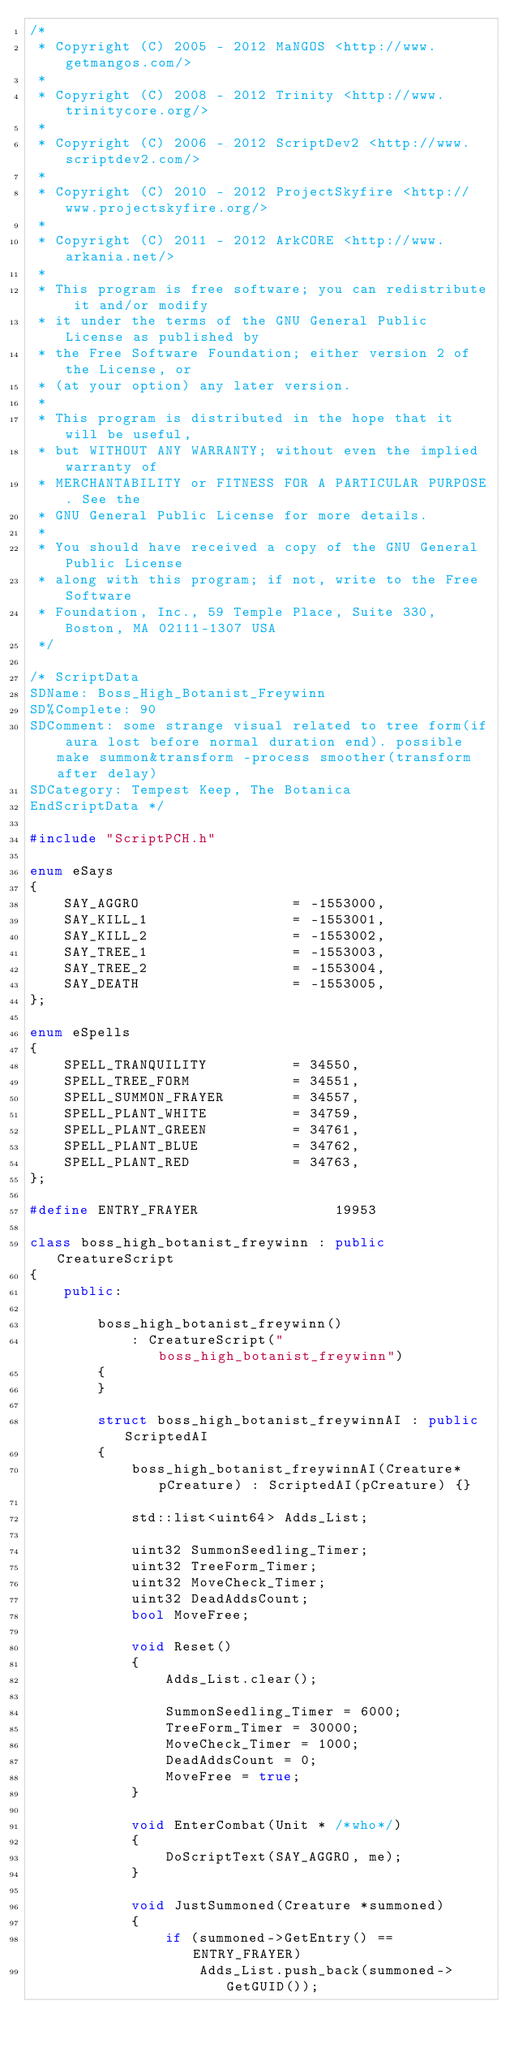<code> <loc_0><loc_0><loc_500><loc_500><_C++_>/*
 * Copyright (C) 2005 - 2012 MaNGOS <http://www.getmangos.com/>
 *
 * Copyright (C) 2008 - 2012 Trinity <http://www.trinitycore.org/>
 *
 * Copyright (C) 2006 - 2012 ScriptDev2 <http://www.scriptdev2.com/>
 *
 * Copyright (C) 2010 - 2012 ProjectSkyfire <http://www.projectskyfire.org/>
 *
 * Copyright (C) 2011 - 2012 ArkCORE <http://www.arkania.net/>
 *
 * This program is free software; you can redistribute it and/or modify
 * it under the terms of the GNU General Public License as published by
 * the Free Software Foundation; either version 2 of the License, or
 * (at your option) any later version.
 *
 * This program is distributed in the hope that it will be useful,
 * but WITHOUT ANY WARRANTY; without even the implied warranty of
 * MERCHANTABILITY or FITNESS FOR A PARTICULAR PURPOSE. See the
 * GNU General Public License for more details.
 *
 * You should have received a copy of the GNU General Public License
 * along with this program; if not, write to the Free Software
 * Foundation, Inc., 59 Temple Place, Suite 330, Boston, MA 02111-1307 USA
 */

/* ScriptData
SDName: Boss_High_Botanist_Freywinn
SD%Complete: 90
SDComment: some strange visual related to tree form(if aura lost before normal duration end). possible make summon&transform -process smoother(transform after delay)
SDCategory: Tempest Keep, The Botanica
EndScriptData */

#include "ScriptPCH.h"

enum eSays
{
    SAY_AGGRO                  = -1553000,
    SAY_KILL_1                 = -1553001,
    SAY_KILL_2                 = -1553002,
    SAY_TREE_1                 = -1553003,
    SAY_TREE_2                 = -1553004,
    SAY_DEATH                  = -1553005,
};

enum eSpells
{
    SPELL_TRANQUILITY          = 34550,
    SPELL_TREE_FORM            = 34551,
    SPELL_SUMMON_FRAYER        = 34557,
    SPELL_PLANT_WHITE          = 34759,
    SPELL_PLANT_GREEN          = 34761,
    SPELL_PLANT_BLUE           = 34762,
    SPELL_PLANT_RED            = 34763,
};

#define ENTRY_FRAYER                19953

class boss_high_botanist_freywinn : public CreatureScript
{
    public:

        boss_high_botanist_freywinn()
            : CreatureScript("boss_high_botanist_freywinn")
        {
        }

        struct boss_high_botanist_freywinnAI : public ScriptedAI
        {
            boss_high_botanist_freywinnAI(Creature* pCreature) : ScriptedAI(pCreature) {}

            std::list<uint64> Adds_List;

            uint32 SummonSeedling_Timer;
            uint32 TreeForm_Timer;
            uint32 MoveCheck_Timer;
            uint32 DeadAddsCount;
            bool MoveFree;

            void Reset()
            {
                Adds_List.clear();

                SummonSeedling_Timer = 6000;
                TreeForm_Timer = 30000;
                MoveCheck_Timer = 1000;
                DeadAddsCount = 0;
                MoveFree = true;
            }

            void EnterCombat(Unit * /*who*/)
            {
                DoScriptText(SAY_AGGRO, me);
            }

            void JustSummoned(Creature *summoned)
            {
                if (summoned->GetEntry() == ENTRY_FRAYER)
                    Adds_List.push_back(summoned->GetGUID());</code> 